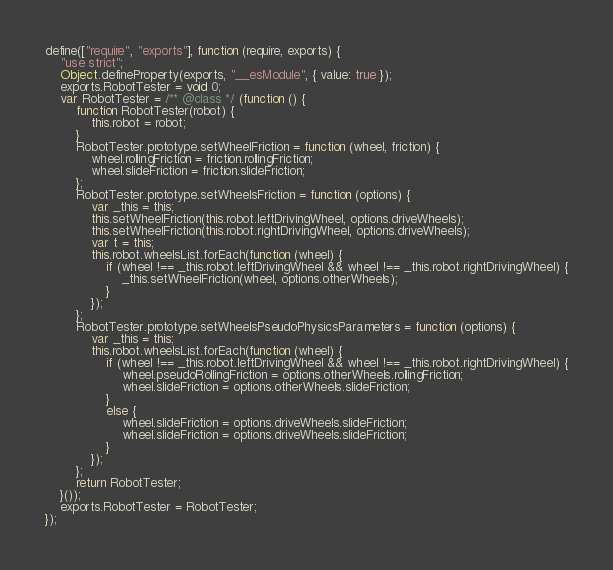Convert code to text. <code><loc_0><loc_0><loc_500><loc_500><_JavaScript_>define(["require", "exports"], function (require, exports) {
    "use strict";
    Object.defineProperty(exports, "__esModule", { value: true });
    exports.RobotTester = void 0;
    var RobotTester = /** @class */ (function () {
        function RobotTester(robot) {
            this.robot = robot;
        }
        RobotTester.prototype.setWheelFriction = function (wheel, friction) {
            wheel.rollingFriction = friction.rollingFriction;
            wheel.slideFriction = friction.slideFriction;
        };
        RobotTester.prototype.setWheelsFriction = function (options) {
            var _this = this;
            this.setWheelFriction(this.robot.leftDrivingWheel, options.driveWheels);
            this.setWheelFriction(this.robot.rightDrivingWheel, options.driveWheels);
            var t = this;
            this.robot.wheelsList.forEach(function (wheel) {
                if (wheel !== _this.robot.leftDrivingWheel && wheel !== _this.robot.rightDrivingWheel) {
                    _this.setWheelFriction(wheel, options.otherWheels);
                }
            });
        };
        RobotTester.prototype.setWheelsPseudoPhysicsParameters = function (options) {
            var _this = this;
            this.robot.wheelsList.forEach(function (wheel) {
                if (wheel !== _this.robot.leftDrivingWheel && wheel !== _this.robot.rightDrivingWheel) {
                    wheel.pseudoRollingFriction = options.otherWheels.rollingFriction;
                    wheel.slideFriction = options.otherWheels.slideFriction;
                }
                else {
                    wheel.slideFriction = options.driveWheels.slideFriction;
                    wheel.slideFriction = options.driveWheels.slideFriction;
                }
            });
        };
        return RobotTester;
    }());
    exports.RobotTester = RobotTester;
});
</code> 